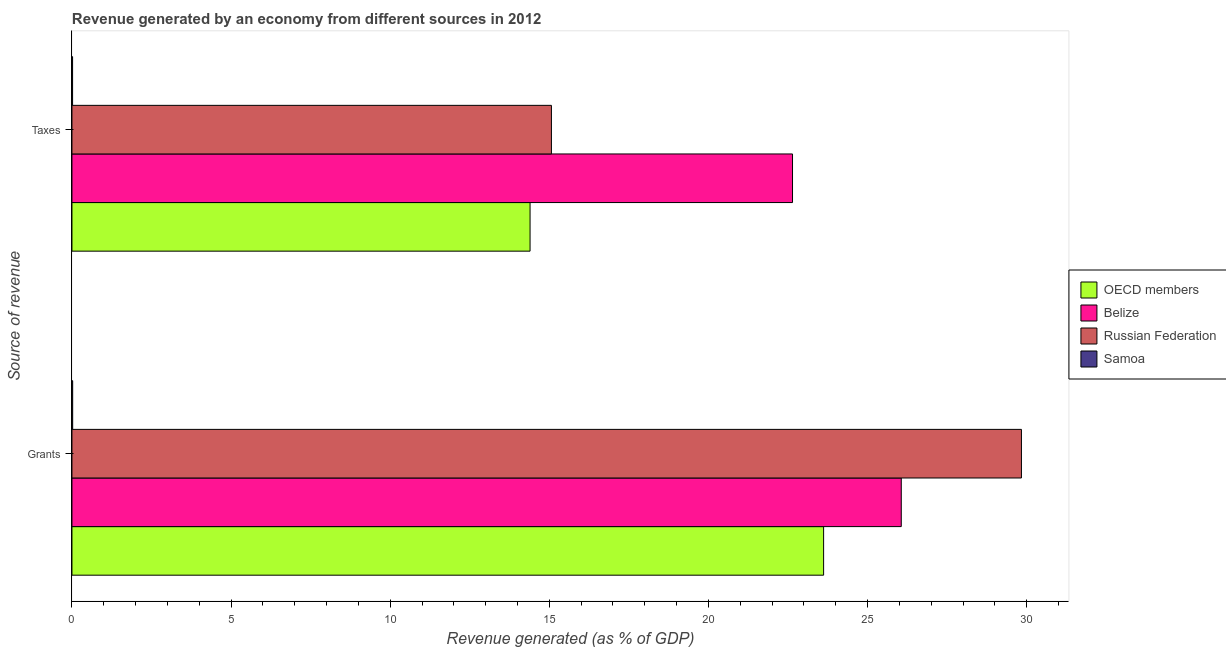How many different coloured bars are there?
Give a very brief answer. 4. Are the number of bars per tick equal to the number of legend labels?
Keep it short and to the point. Yes. Are the number of bars on each tick of the Y-axis equal?
Give a very brief answer. Yes. How many bars are there on the 1st tick from the bottom?
Provide a succinct answer. 4. What is the label of the 2nd group of bars from the top?
Provide a short and direct response. Grants. What is the revenue generated by grants in Russian Federation?
Keep it short and to the point. 29.83. Across all countries, what is the maximum revenue generated by grants?
Offer a very short reply. 29.83. Across all countries, what is the minimum revenue generated by taxes?
Give a very brief answer. 0.02. In which country was the revenue generated by grants maximum?
Give a very brief answer. Russian Federation. In which country was the revenue generated by taxes minimum?
Ensure brevity in your answer.  Samoa. What is the total revenue generated by grants in the graph?
Your answer should be compact. 79.53. What is the difference between the revenue generated by grants in Samoa and that in OECD members?
Make the answer very short. -23.6. What is the difference between the revenue generated by grants in Belize and the revenue generated by taxes in Samoa?
Give a very brief answer. 26.04. What is the average revenue generated by grants per country?
Your answer should be compact. 19.88. What is the difference between the revenue generated by taxes and revenue generated by grants in OECD members?
Ensure brevity in your answer.  -9.22. What is the ratio of the revenue generated by taxes in Belize to that in OECD members?
Your answer should be very brief. 1.57. In how many countries, is the revenue generated by taxes greater than the average revenue generated by taxes taken over all countries?
Ensure brevity in your answer.  3. What does the 3rd bar from the top in Taxes represents?
Provide a short and direct response. Belize. What does the 1st bar from the bottom in Grants represents?
Offer a very short reply. OECD members. How many bars are there?
Ensure brevity in your answer.  8. What is the difference between two consecutive major ticks on the X-axis?
Your response must be concise. 5. Are the values on the major ticks of X-axis written in scientific E-notation?
Your answer should be very brief. No. Does the graph contain grids?
Give a very brief answer. No. Where does the legend appear in the graph?
Your answer should be very brief. Center right. How many legend labels are there?
Provide a short and direct response. 4. How are the legend labels stacked?
Ensure brevity in your answer.  Vertical. What is the title of the graph?
Your answer should be compact. Revenue generated by an economy from different sources in 2012. Does "Jamaica" appear as one of the legend labels in the graph?
Provide a succinct answer. No. What is the label or title of the X-axis?
Offer a terse response. Revenue generated (as % of GDP). What is the label or title of the Y-axis?
Make the answer very short. Source of revenue. What is the Revenue generated (as % of GDP) in OECD members in Grants?
Make the answer very short. 23.62. What is the Revenue generated (as % of GDP) in Belize in Grants?
Make the answer very short. 26.06. What is the Revenue generated (as % of GDP) in Russian Federation in Grants?
Offer a very short reply. 29.83. What is the Revenue generated (as % of GDP) of Samoa in Grants?
Keep it short and to the point. 0.02. What is the Revenue generated (as % of GDP) in OECD members in Taxes?
Keep it short and to the point. 14.39. What is the Revenue generated (as % of GDP) of Belize in Taxes?
Ensure brevity in your answer.  22.64. What is the Revenue generated (as % of GDP) in Russian Federation in Taxes?
Ensure brevity in your answer.  15.07. What is the Revenue generated (as % of GDP) of Samoa in Taxes?
Your answer should be compact. 0.02. Across all Source of revenue, what is the maximum Revenue generated (as % of GDP) in OECD members?
Your answer should be compact. 23.62. Across all Source of revenue, what is the maximum Revenue generated (as % of GDP) of Belize?
Give a very brief answer. 26.06. Across all Source of revenue, what is the maximum Revenue generated (as % of GDP) in Russian Federation?
Your answer should be compact. 29.83. Across all Source of revenue, what is the maximum Revenue generated (as % of GDP) of Samoa?
Provide a short and direct response. 0.02. Across all Source of revenue, what is the minimum Revenue generated (as % of GDP) in OECD members?
Keep it short and to the point. 14.39. Across all Source of revenue, what is the minimum Revenue generated (as % of GDP) in Belize?
Ensure brevity in your answer.  22.64. Across all Source of revenue, what is the minimum Revenue generated (as % of GDP) of Russian Federation?
Offer a terse response. 15.07. Across all Source of revenue, what is the minimum Revenue generated (as % of GDP) in Samoa?
Keep it short and to the point. 0.02. What is the total Revenue generated (as % of GDP) in OECD members in the graph?
Make the answer very short. 38.01. What is the total Revenue generated (as % of GDP) of Belize in the graph?
Make the answer very short. 48.7. What is the total Revenue generated (as % of GDP) in Russian Federation in the graph?
Offer a terse response. 44.9. What is the total Revenue generated (as % of GDP) in Samoa in the graph?
Provide a short and direct response. 0.04. What is the difference between the Revenue generated (as % of GDP) of OECD members in Grants and that in Taxes?
Make the answer very short. 9.22. What is the difference between the Revenue generated (as % of GDP) of Belize in Grants and that in Taxes?
Provide a short and direct response. 3.42. What is the difference between the Revenue generated (as % of GDP) of Russian Federation in Grants and that in Taxes?
Your answer should be compact. 14.77. What is the difference between the Revenue generated (as % of GDP) in Samoa in Grants and that in Taxes?
Offer a terse response. 0. What is the difference between the Revenue generated (as % of GDP) of OECD members in Grants and the Revenue generated (as % of GDP) of Belize in Taxes?
Provide a succinct answer. 0.98. What is the difference between the Revenue generated (as % of GDP) in OECD members in Grants and the Revenue generated (as % of GDP) in Russian Federation in Taxes?
Your response must be concise. 8.55. What is the difference between the Revenue generated (as % of GDP) of OECD members in Grants and the Revenue generated (as % of GDP) of Samoa in Taxes?
Your answer should be very brief. 23.6. What is the difference between the Revenue generated (as % of GDP) in Belize in Grants and the Revenue generated (as % of GDP) in Russian Federation in Taxes?
Your response must be concise. 10.99. What is the difference between the Revenue generated (as % of GDP) in Belize in Grants and the Revenue generated (as % of GDP) in Samoa in Taxes?
Your answer should be compact. 26.04. What is the difference between the Revenue generated (as % of GDP) in Russian Federation in Grants and the Revenue generated (as % of GDP) in Samoa in Taxes?
Offer a very short reply. 29.81. What is the average Revenue generated (as % of GDP) of OECD members per Source of revenue?
Provide a short and direct response. 19.01. What is the average Revenue generated (as % of GDP) in Belize per Source of revenue?
Ensure brevity in your answer.  24.35. What is the average Revenue generated (as % of GDP) of Russian Federation per Source of revenue?
Your response must be concise. 22.45. What is the average Revenue generated (as % of GDP) of Samoa per Source of revenue?
Offer a very short reply. 0.02. What is the difference between the Revenue generated (as % of GDP) in OECD members and Revenue generated (as % of GDP) in Belize in Grants?
Your answer should be very brief. -2.44. What is the difference between the Revenue generated (as % of GDP) of OECD members and Revenue generated (as % of GDP) of Russian Federation in Grants?
Your answer should be compact. -6.22. What is the difference between the Revenue generated (as % of GDP) in OECD members and Revenue generated (as % of GDP) in Samoa in Grants?
Make the answer very short. 23.6. What is the difference between the Revenue generated (as % of GDP) in Belize and Revenue generated (as % of GDP) in Russian Federation in Grants?
Ensure brevity in your answer.  -3.78. What is the difference between the Revenue generated (as % of GDP) in Belize and Revenue generated (as % of GDP) in Samoa in Grants?
Offer a terse response. 26.04. What is the difference between the Revenue generated (as % of GDP) of Russian Federation and Revenue generated (as % of GDP) of Samoa in Grants?
Provide a short and direct response. 29.81. What is the difference between the Revenue generated (as % of GDP) of OECD members and Revenue generated (as % of GDP) of Belize in Taxes?
Provide a short and direct response. -8.25. What is the difference between the Revenue generated (as % of GDP) in OECD members and Revenue generated (as % of GDP) in Russian Federation in Taxes?
Provide a short and direct response. -0.67. What is the difference between the Revenue generated (as % of GDP) of OECD members and Revenue generated (as % of GDP) of Samoa in Taxes?
Provide a succinct answer. 14.37. What is the difference between the Revenue generated (as % of GDP) of Belize and Revenue generated (as % of GDP) of Russian Federation in Taxes?
Provide a succinct answer. 7.58. What is the difference between the Revenue generated (as % of GDP) in Belize and Revenue generated (as % of GDP) in Samoa in Taxes?
Offer a terse response. 22.62. What is the difference between the Revenue generated (as % of GDP) in Russian Federation and Revenue generated (as % of GDP) in Samoa in Taxes?
Your response must be concise. 15.05. What is the ratio of the Revenue generated (as % of GDP) of OECD members in Grants to that in Taxes?
Give a very brief answer. 1.64. What is the ratio of the Revenue generated (as % of GDP) in Belize in Grants to that in Taxes?
Give a very brief answer. 1.15. What is the ratio of the Revenue generated (as % of GDP) in Russian Federation in Grants to that in Taxes?
Keep it short and to the point. 1.98. What is the ratio of the Revenue generated (as % of GDP) in Samoa in Grants to that in Taxes?
Offer a terse response. 1.16. What is the difference between the highest and the second highest Revenue generated (as % of GDP) of OECD members?
Keep it short and to the point. 9.22. What is the difference between the highest and the second highest Revenue generated (as % of GDP) of Belize?
Provide a short and direct response. 3.42. What is the difference between the highest and the second highest Revenue generated (as % of GDP) in Russian Federation?
Your response must be concise. 14.77. What is the difference between the highest and the second highest Revenue generated (as % of GDP) in Samoa?
Give a very brief answer. 0. What is the difference between the highest and the lowest Revenue generated (as % of GDP) of OECD members?
Offer a very short reply. 9.22. What is the difference between the highest and the lowest Revenue generated (as % of GDP) of Belize?
Your response must be concise. 3.42. What is the difference between the highest and the lowest Revenue generated (as % of GDP) in Russian Federation?
Your answer should be compact. 14.77. What is the difference between the highest and the lowest Revenue generated (as % of GDP) of Samoa?
Your answer should be very brief. 0. 